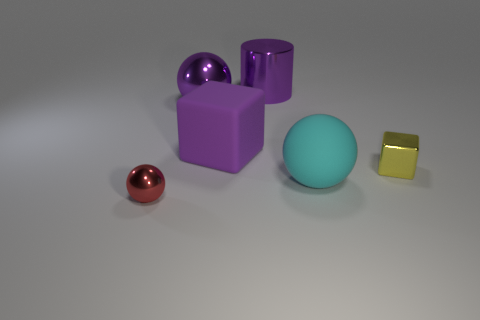What is the size of the metal ball behind the small shiny object in front of the small metal block?
Provide a succinct answer. Large. Do the tiny red shiny object that is left of the purple metallic sphere and the small yellow thing have the same shape?
Your response must be concise. No. There is a cyan thing that is the same shape as the small red object; what is its material?
Provide a short and direct response. Rubber. What number of things are either rubber things that are in front of the rubber cube or shiny balls in front of the small metal block?
Ensure brevity in your answer.  2. There is a big metal ball; is its color the same as the large metallic thing that is on the right side of the purple block?
Provide a succinct answer. Yes. What shape is the object that is the same material as the big cyan ball?
Make the answer very short. Cube. How many large purple metallic objects are there?
Your answer should be very brief. 2. How many objects are either large balls that are left of the cylinder or big cyan rubber spheres?
Ensure brevity in your answer.  2. Is the color of the large ball that is left of the large metal cylinder the same as the large cylinder?
Give a very brief answer. Yes. What number of other things are the same color as the tiny metal cube?
Give a very brief answer. 0. 